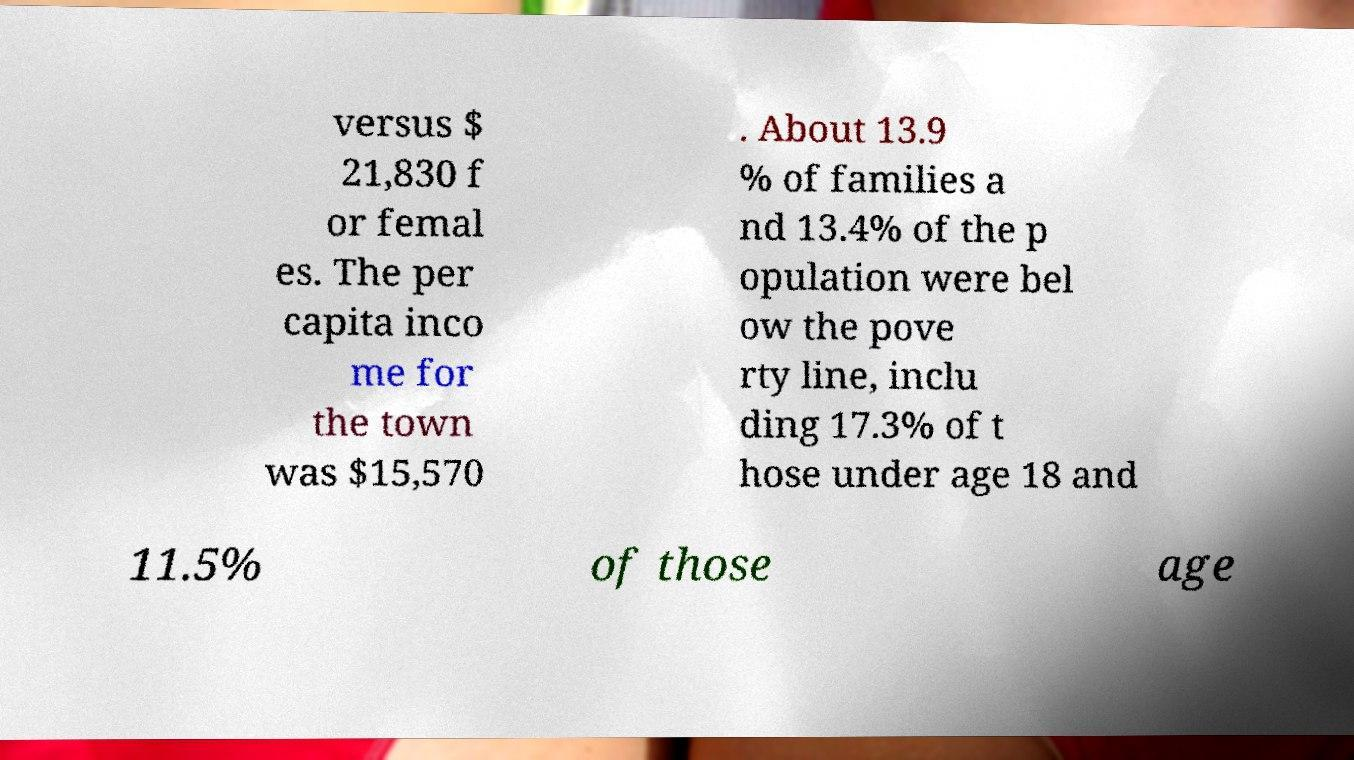What messages or text are displayed in this image? I need them in a readable, typed format. versus $ 21,830 f or femal es. The per capita inco me for the town was $15,570 . About 13.9 % of families a nd 13.4% of the p opulation were bel ow the pove rty line, inclu ding 17.3% of t hose under age 18 and 11.5% of those age 